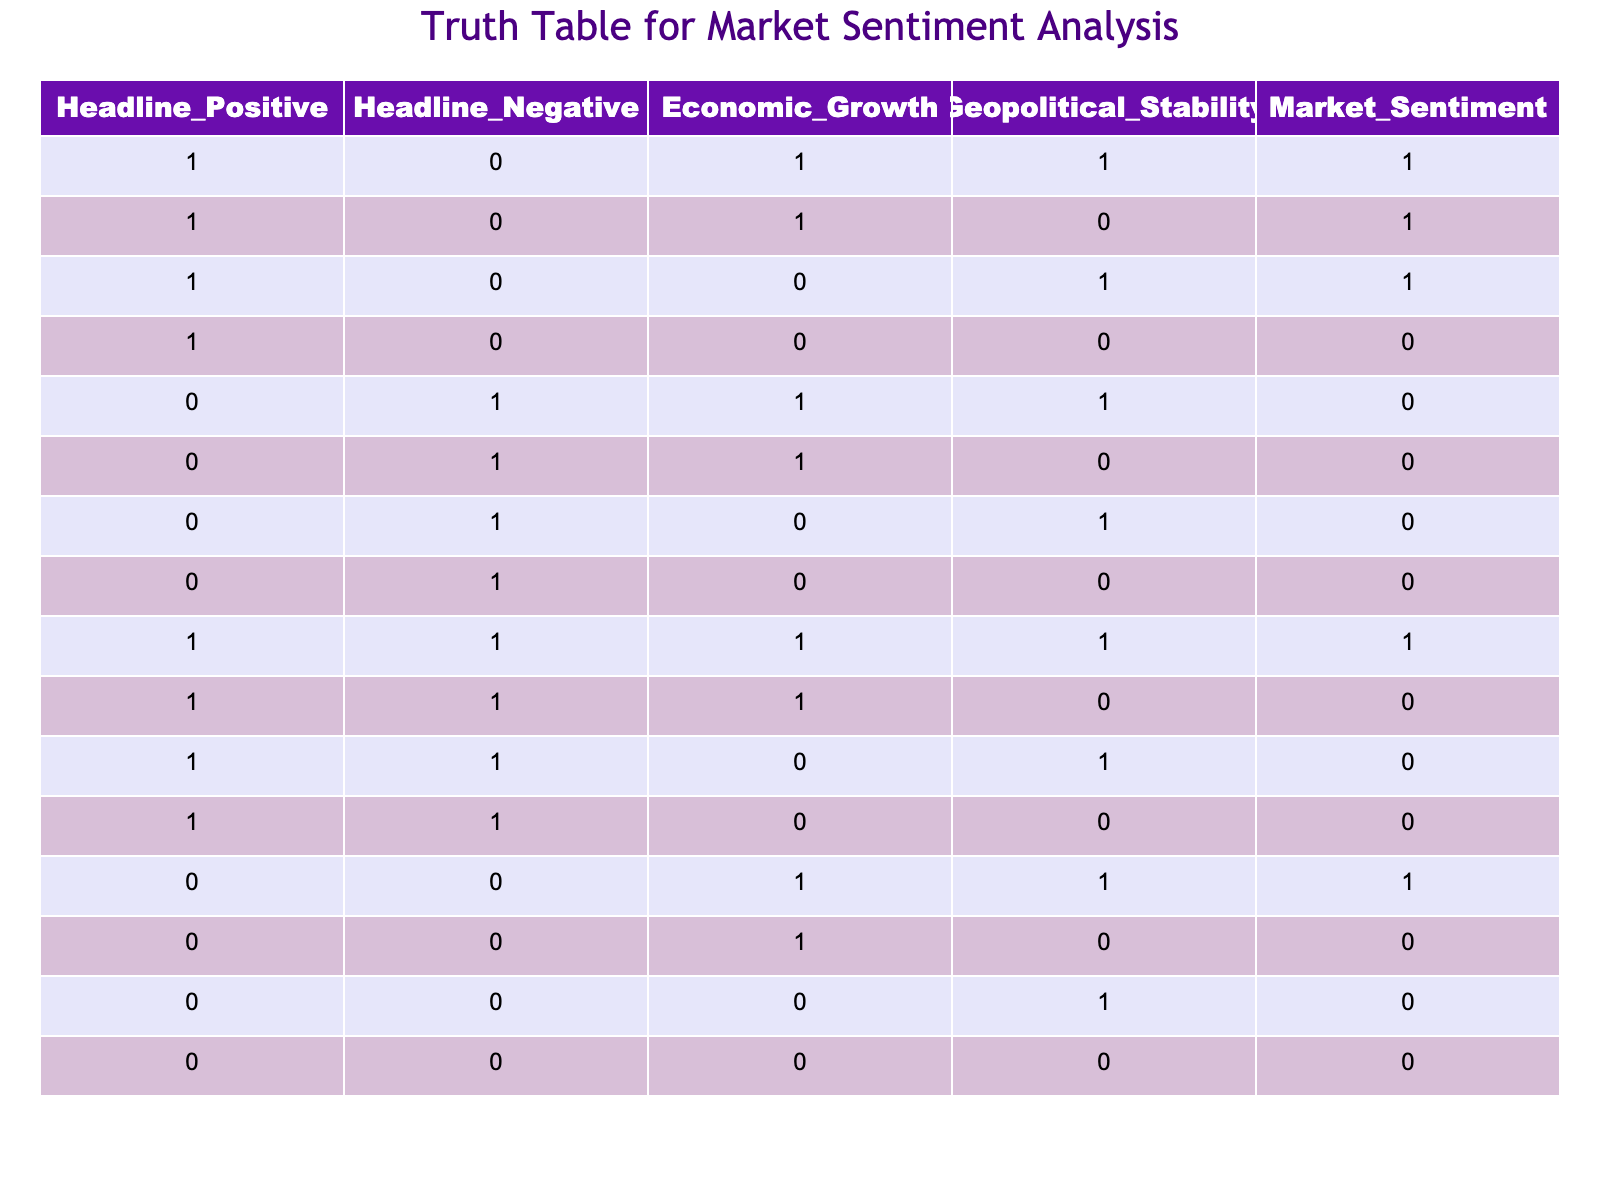What is the Market Sentiment when Headline is Positive and Economic Growth is 0? In the table, when the Headline_Positive is 1 and Economic_Growth is 0, there are two rows: one with Geopolitical_Stability as 1 (Market_Sentiment is 0) and another with Geopolitical_Stability as 0 (Market_Sentiment is also 0). Thus, in both instances, Market_Sentiment is 0.
Answer: 0 How many instances show a positive Market Sentiment? Scanning through the Market_Sentiment column, the positive values (1) appear in rows 1, 2, 3, 9, and 13. Counting these gives a total of 5 instances where the Market Sentiment is positive (1).
Answer: 5 If the Geopolitical Stability is 1, what is the percentage of positive Market Sentiment? From the rows where Geopolitical_Stability is 1, we have rows 1, 2, 3, 5, 9, and 13 - totaling 6 entries. Among these, only rows 1 and 9 show a positive Market Sentiment, leading to 2 positive instances. The percentage is (2 positive / 6 total) * 100% = 33.33%.
Answer: 33.33% Is there any case where both Headline_Negative and Market Sentiment are 1? By inspecting the rows in the table, Headline_Negative is 1 in rows 5, 6, 7, 8, 10, 11, 12, and 15. None of these rows have Market_Sentiment as 1; thus, it’s confirmed that there are no cases where both Headline_Negative is 1 and Market Sentiment is 1.
Answer: No What is the total number of instances where Economic Growth is 1 and Market Sentiment is 0? In the table, Economic_Growth is 1 for rows 1, 2, 5, 9, and 13. Among these, only rows 5 and 12 show a Market Sentiment of 0. Therefore, there are 2 instances where Economic Growth is 1 and Market Sentiment is 0.
Answer: 2 When both Headline_Positive and Headline_Negative are 1, what is the Market Sentiment? Checking the table reveals only one row with both Headline_Positive (1) and Headline_Negative (1), which is row 9. In this case, the Market_Sentiment is 1.
Answer: 1 What is the difference between rows with positive Headline and those with negative Headline regarding Market Sentiment? Rows with Headline_Positive show positive Market Sentiment in 5 instances whereas Headline_Negative does not show any positive Market Sentiment. Therefore, there is a clear difference: 5 instances with Headline_Positive and 0 with Headline_Negative in terms of positive Market Sentiment.
Answer: 5 What is the overall trend of Market Sentiment concerning Geopolitical Stability when Economic Growth is 1? There are 4 instances where Economic_Growth is 1 (rows 1, 2, 9, 13) and all show Geopolitical_Stability either being 1 or 0 with mixed Market Sentiment results (1, 1 for Geopolitical_Stability 1 and 0 gives 0). Therefore, it suggests a lack of clear positive sentiment when Economic Growth is 1 across rows with differing Geopolitical Stability.
Answer: Mixed 